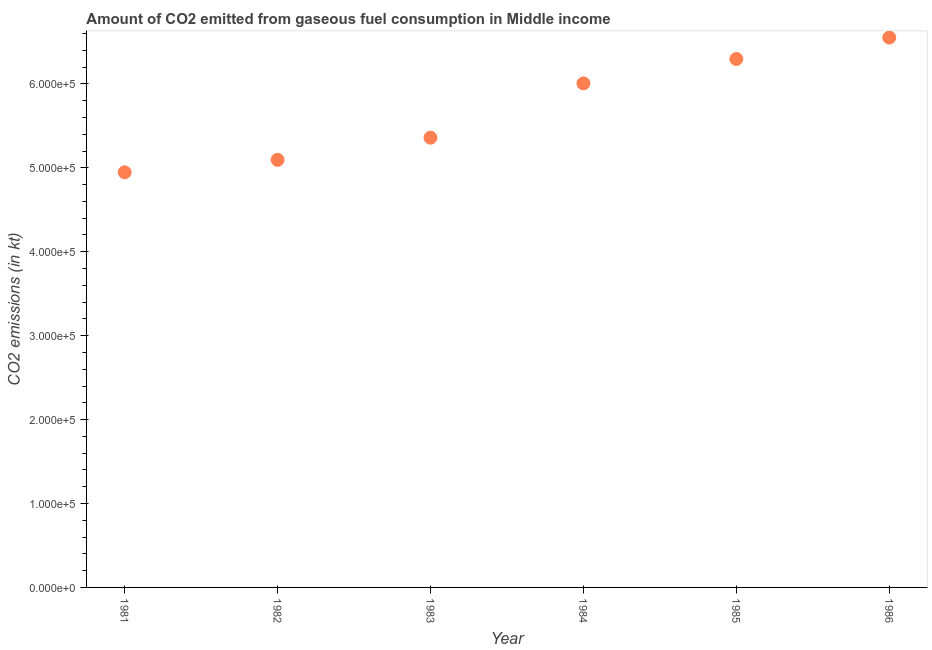What is the co2 emissions from gaseous fuel consumption in 1983?
Make the answer very short. 5.36e+05. Across all years, what is the maximum co2 emissions from gaseous fuel consumption?
Keep it short and to the point. 6.55e+05. Across all years, what is the minimum co2 emissions from gaseous fuel consumption?
Your answer should be very brief. 4.95e+05. In which year was the co2 emissions from gaseous fuel consumption maximum?
Offer a very short reply. 1986. What is the sum of the co2 emissions from gaseous fuel consumption?
Offer a very short reply. 3.43e+06. What is the difference between the co2 emissions from gaseous fuel consumption in 1981 and 1982?
Make the answer very short. -1.48e+04. What is the average co2 emissions from gaseous fuel consumption per year?
Offer a terse response. 5.71e+05. What is the median co2 emissions from gaseous fuel consumption?
Offer a terse response. 5.68e+05. Do a majority of the years between 1984 and 1982 (inclusive) have co2 emissions from gaseous fuel consumption greater than 520000 kt?
Your answer should be compact. No. What is the ratio of the co2 emissions from gaseous fuel consumption in 1981 to that in 1984?
Give a very brief answer. 0.82. Is the co2 emissions from gaseous fuel consumption in 1982 less than that in 1983?
Make the answer very short. Yes. What is the difference between the highest and the second highest co2 emissions from gaseous fuel consumption?
Keep it short and to the point. 2.55e+04. Is the sum of the co2 emissions from gaseous fuel consumption in 1981 and 1983 greater than the maximum co2 emissions from gaseous fuel consumption across all years?
Provide a succinct answer. Yes. What is the difference between the highest and the lowest co2 emissions from gaseous fuel consumption?
Offer a terse response. 1.61e+05. How many years are there in the graph?
Provide a short and direct response. 6. What is the difference between two consecutive major ticks on the Y-axis?
Make the answer very short. 1.00e+05. Does the graph contain any zero values?
Make the answer very short. No. Does the graph contain grids?
Provide a short and direct response. No. What is the title of the graph?
Your answer should be very brief. Amount of CO2 emitted from gaseous fuel consumption in Middle income. What is the label or title of the Y-axis?
Your answer should be compact. CO2 emissions (in kt). What is the CO2 emissions (in kt) in 1981?
Make the answer very short. 4.95e+05. What is the CO2 emissions (in kt) in 1982?
Provide a short and direct response. 5.09e+05. What is the CO2 emissions (in kt) in 1983?
Keep it short and to the point. 5.36e+05. What is the CO2 emissions (in kt) in 1984?
Make the answer very short. 6.01e+05. What is the CO2 emissions (in kt) in 1985?
Offer a terse response. 6.30e+05. What is the CO2 emissions (in kt) in 1986?
Offer a very short reply. 6.55e+05. What is the difference between the CO2 emissions (in kt) in 1981 and 1982?
Your answer should be compact. -1.48e+04. What is the difference between the CO2 emissions (in kt) in 1981 and 1983?
Ensure brevity in your answer.  -4.12e+04. What is the difference between the CO2 emissions (in kt) in 1981 and 1984?
Offer a very short reply. -1.06e+05. What is the difference between the CO2 emissions (in kt) in 1981 and 1985?
Your answer should be compact. -1.35e+05. What is the difference between the CO2 emissions (in kt) in 1981 and 1986?
Give a very brief answer. -1.61e+05. What is the difference between the CO2 emissions (in kt) in 1982 and 1983?
Ensure brevity in your answer.  -2.64e+04. What is the difference between the CO2 emissions (in kt) in 1982 and 1984?
Your response must be concise. -9.11e+04. What is the difference between the CO2 emissions (in kt) in 1982 and 1985?
Ensure brevity in your answer.  -1.20e+05. What is the difference between the CO2 emissions (in kt) in 1982 and 1986?
Give a very brief answer. -1.46e+05. What is the difference between the CO2 emissions (in kt) in 1983 and 1984?
Your answer should be very brief. -6.47e+04. What is the difference between the CO2 emissions (in kt) in 1983 and 1985?
Offer a very short reply. -9.38e+04. What is the difference between the CO2 emissions (in kt) in 1983 and 1986?
Offer a very short reply. -1.19e+05. What is the difference between the CO2 emissions (in kt) in 1984 and 1985?
Give a very brief answer. -2.91e+04. What is the difference between the CO2 emissions (in kt) in 1984 and 1986?
Your answer should be compact. -5.46e+04. What is the difference between the CO2 emissions (in kt) in 1985 and 1986?
Your answer should be very brief. -2.55e+04. What is the ratio of the CO2 emissions (in kt) in 1981 to that in 1982?
Your answer should be compact. 0.97. What is the ratio of the CO2 emissions (in kt) in 1981 to that in 1983?
Give a very brief answer. 0.92. What is the ratio of the CO2 emissions (in kt) in 1981 to that in 1984?
Offer a very short reply. 0.82. What is the ratio of the CO2 emissions (in kt) in 1981 to that in 1985?
Provide a succinct answer. 0.79. What is the ratio of the CO2 emissions (in kt) in 1981 to that in 1986?
Your answer should be very brief. 0.76. What is the ratio of the CO2 emissions (in kt) in 1982 to that in 1983?
Offer a terse response. 0.95. What is the ratio of the CO2 emissions (in kt) in 1982 to that in 1984?
Make the answer very short. 0.85. What is the ratio of the CO2 emissions (in kt) in 1982 to that in 1985?
Keep it short and to the point. 0.81. What is the ratio of the CO2 emissions (in kt) in 1982 to that in 1986?
Provide a short and direct response. 0.78. What is the ratio of the CO2 emissions (in kt) in 1983 to that in 1984?
Give a very brief answer. 0.89. What is the ratio of the CO2 emissions (in kt) in 1983 to that in 1985?
Provide a short and direct response. 0.85. What is the ratio of the CO2 emissions (in kt) in 1983 to that in 1986?
Provide a succinct answer. 0.82. What is the ratio of the CO2 emissions (in kt) in 1984 to that in 1985?
Offer a terse response. 0.95. What is the ratio of the CO2 emissions (in kt) in 1984 to that in 1986?
Provide a short and direct response. 0.92. 